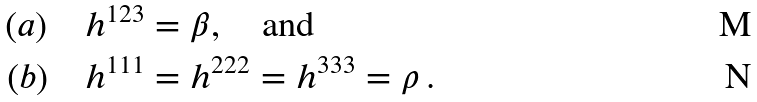Convert formula to latex. <formula><loc_0><loc_0><loc_500><loc_500>( a ) & \quad h ^ { 1 2 3 } = { \beta } , \quad \text {and} \\ ( b ) & \quad h ^ { 1 1 1 } = h ^ { 2 2 2 } = h ^ { 3 3 3 } = \rho \, .</formula> 